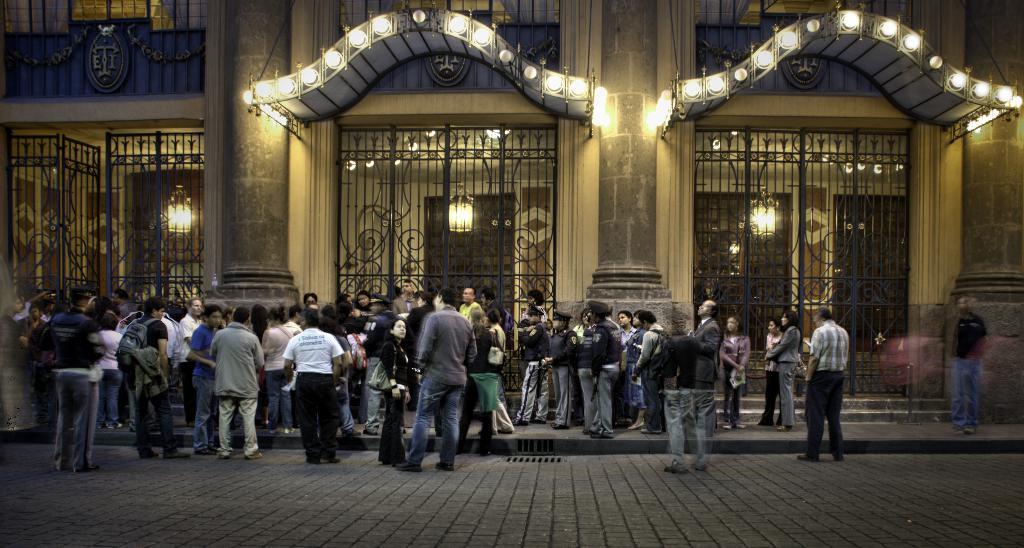Could you give a brief overview of what you see in this image? In this picture we can see a building, gates and lights. We can see people near to the building. At the bottom portion of the picture we can see the road. 